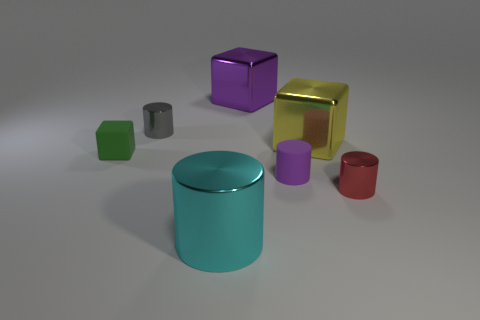Add 3 gray cylinders. How many objects exist? 10 Subtract all cubes. How many objects are left? 4 Add 6 red metallic things. How many red metallic things are left? 7 Add 6 large cyan cylinders. How many large cyan cylinders exist? 7 Subtract 1 cyan cylinders. How many objects are left? 6 Subtract all red blocks. Subtract all green rubber objects. How many objects are left? 6 